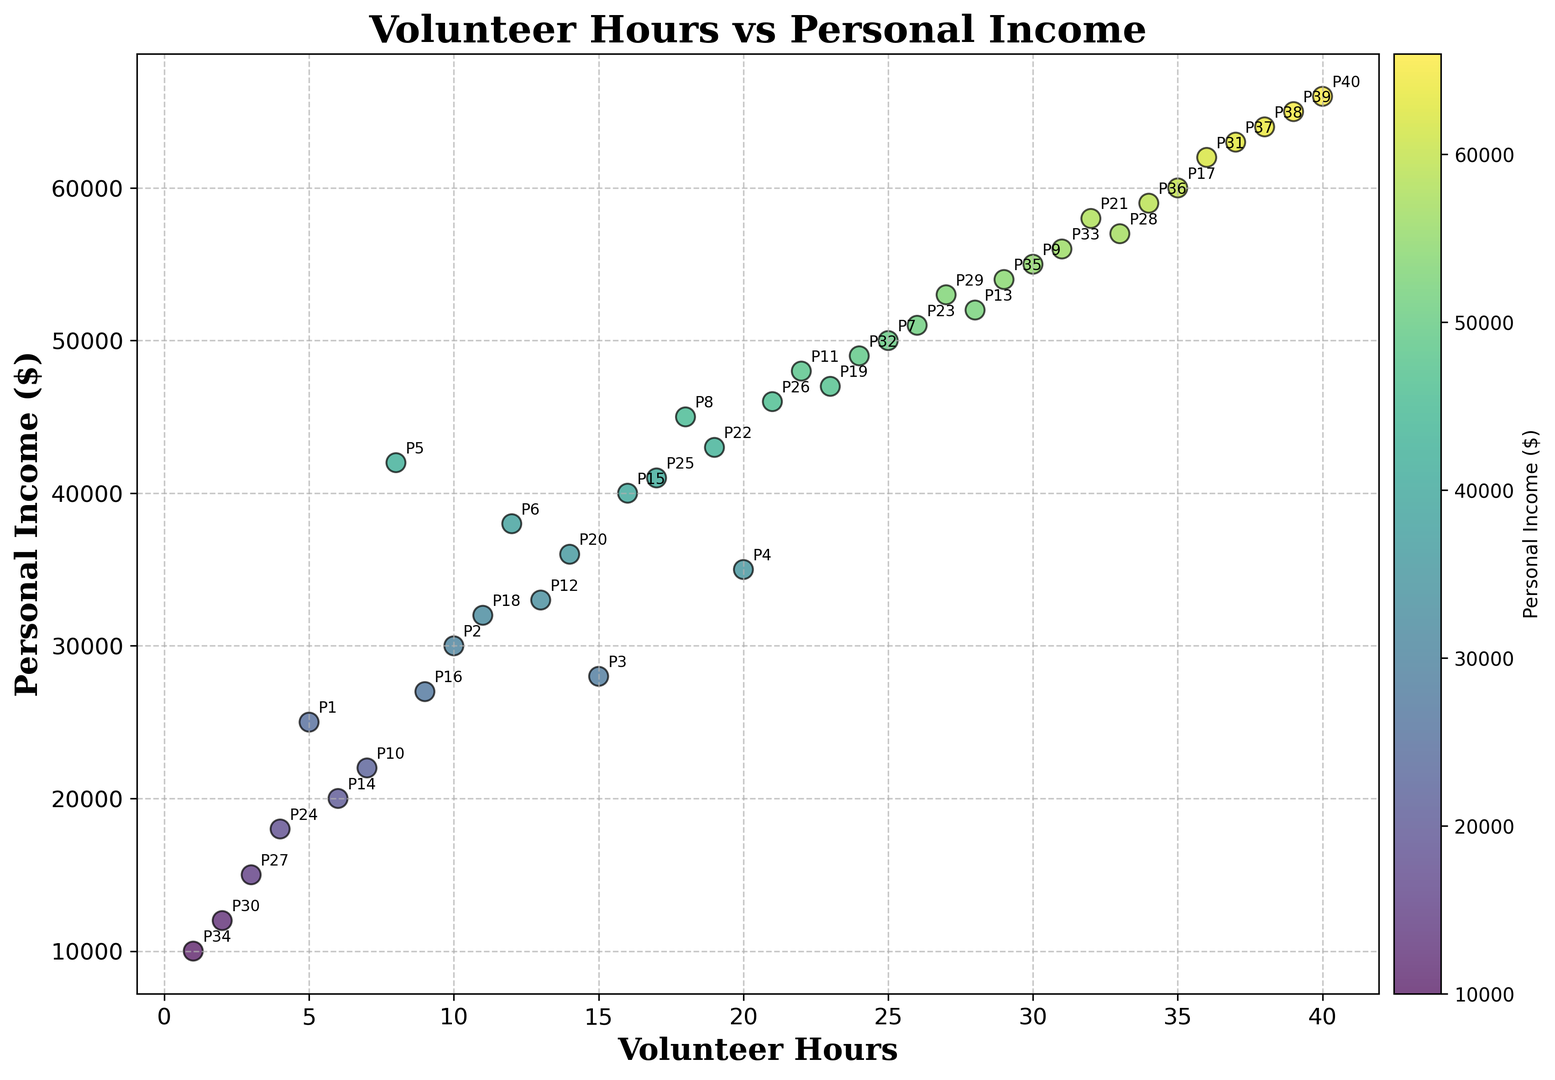Which data point has the highest personal income? The highest personal income is represented by the data point with the greatest value on the y-axis (Personal Income). Observing the scatter plot, the point at (40, 66000) is the highest.
Answer: The data point at (40, 66000) What is the average number of volunteer hours for participants with a personal income above $50,000? Calculate the average of the volunteer hours for participants whose personal income exceeds $50,000. Data points satisfying this condition are (25, 50000), (30, 55000), (28, 52000), (32, 58000), (26, 51000), (33, 57000), (27, 53000), (36, 62000), (29, 54000), (34, 59000), (37, 63000), (38, 64000), (39, 65000), and (40, 66000). Adding their volunteer hours and dividing by 14: (25+30+28+32+26+33+27+36+29+34+37+38+39+40)/14 = 31
Answer: 31 How many participants volunteer more than 20 hours? Count the points where the x-axis value (Volunteer Hours) is greater than 20. Observing the scatter plot, the points are (22, 48000), (25, 50000), (28, 52000), (30, 55000), (32, 58000), (23, 47000), (27, 53000), (35, 60000), (33, 57000), (36, 62000), (24, 49000), (31, 56000), (29, 54000), (34, 59000), (37, 63000), (38, 64000), (39, 65000), (40, 66000). There are 18 such points.
Answer: 18 Which participant has the lowest personal income? Identify the data point with the smallest value on the y-axis (Personal Income). Observing the scatter plot, the point at (1, 10000) is the lowest.
Answer: The data point at (1, 10000) Is there a strong correlation between volunteer hours and personal income? Assess the overall trend of the points on the scatter plot. If points tend to move in a clear upward direction as x (Volunteer Hours) increases, this indicates a positive correlation. Observing the scatter plot, points generally show an upward direction.
Answer: Yes, there is a positive correlation What is the difference in personal income between the participant with 5 volunteer hours and the participant with 10 volunteer hours? Locate the points (5, 25000) and (10, 30000). The difference in income is 30000 - 25000 = 5000.
Answer: 5000 Which visual attribute is used to differentiate the personal income levels in the scatter plot? Observe the elements and general visual layout of the scatter plot. Participants' personal incomes are differentiated through a color gradient indicated by the color bar.
Answer: Color gradient For the participant with 28 volunteer hours, what is their personal income and how does it compare to the participant with 12 volunteer hours? Locate the points (28, 52000) and (12, 38000). Compare 52000 and 38000.
Answer: 52000, 52000 is higher than 38000 What is the combined personal income of the participants with exactly 15 and 20 volunteer hours? Locate the points (15, 28000) and (20, 35000). Add the income values: 28000 + 35000 = 63000.
Answer: 63000 